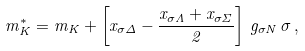<formula> <loc_0><loc_0><loc_500><loc_500>m _ { K } ^ { * } = m _ { K } + \left [ x _ { \sigma \Delta } - \frac { x _ { \sigma \Lambda } + x _ { \sigma \Sigma } } { 2 } \right ] \, g _ { \sigma N } \, \sigma \, ,</formula> 